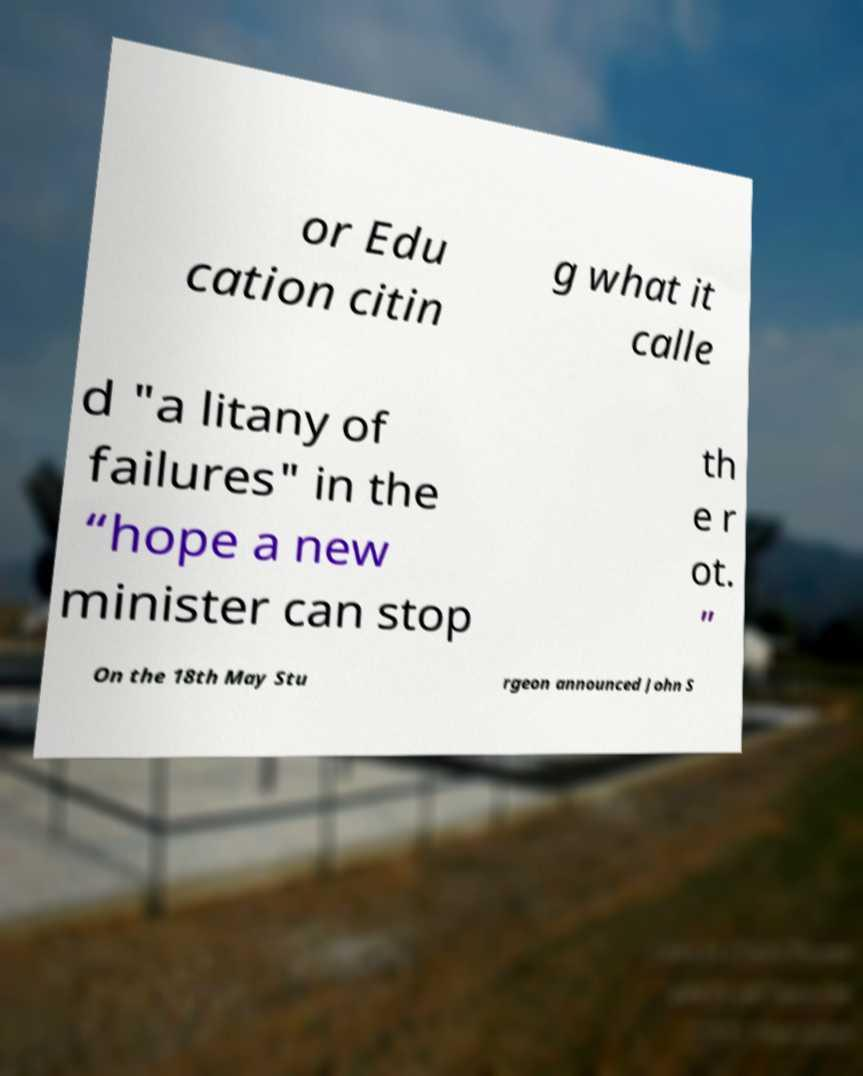Could you assist in decoding the text presented in this image and type it out clearly? or Edu cation citin g what it calle d "a litany of failures" in the “hope a new minister can stop th e r ot. ” On the 18th May Stu rgeon announced John S 